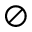<formula> <loc_0><loc_0><loc_500><loc_500>\oslash</formula> 